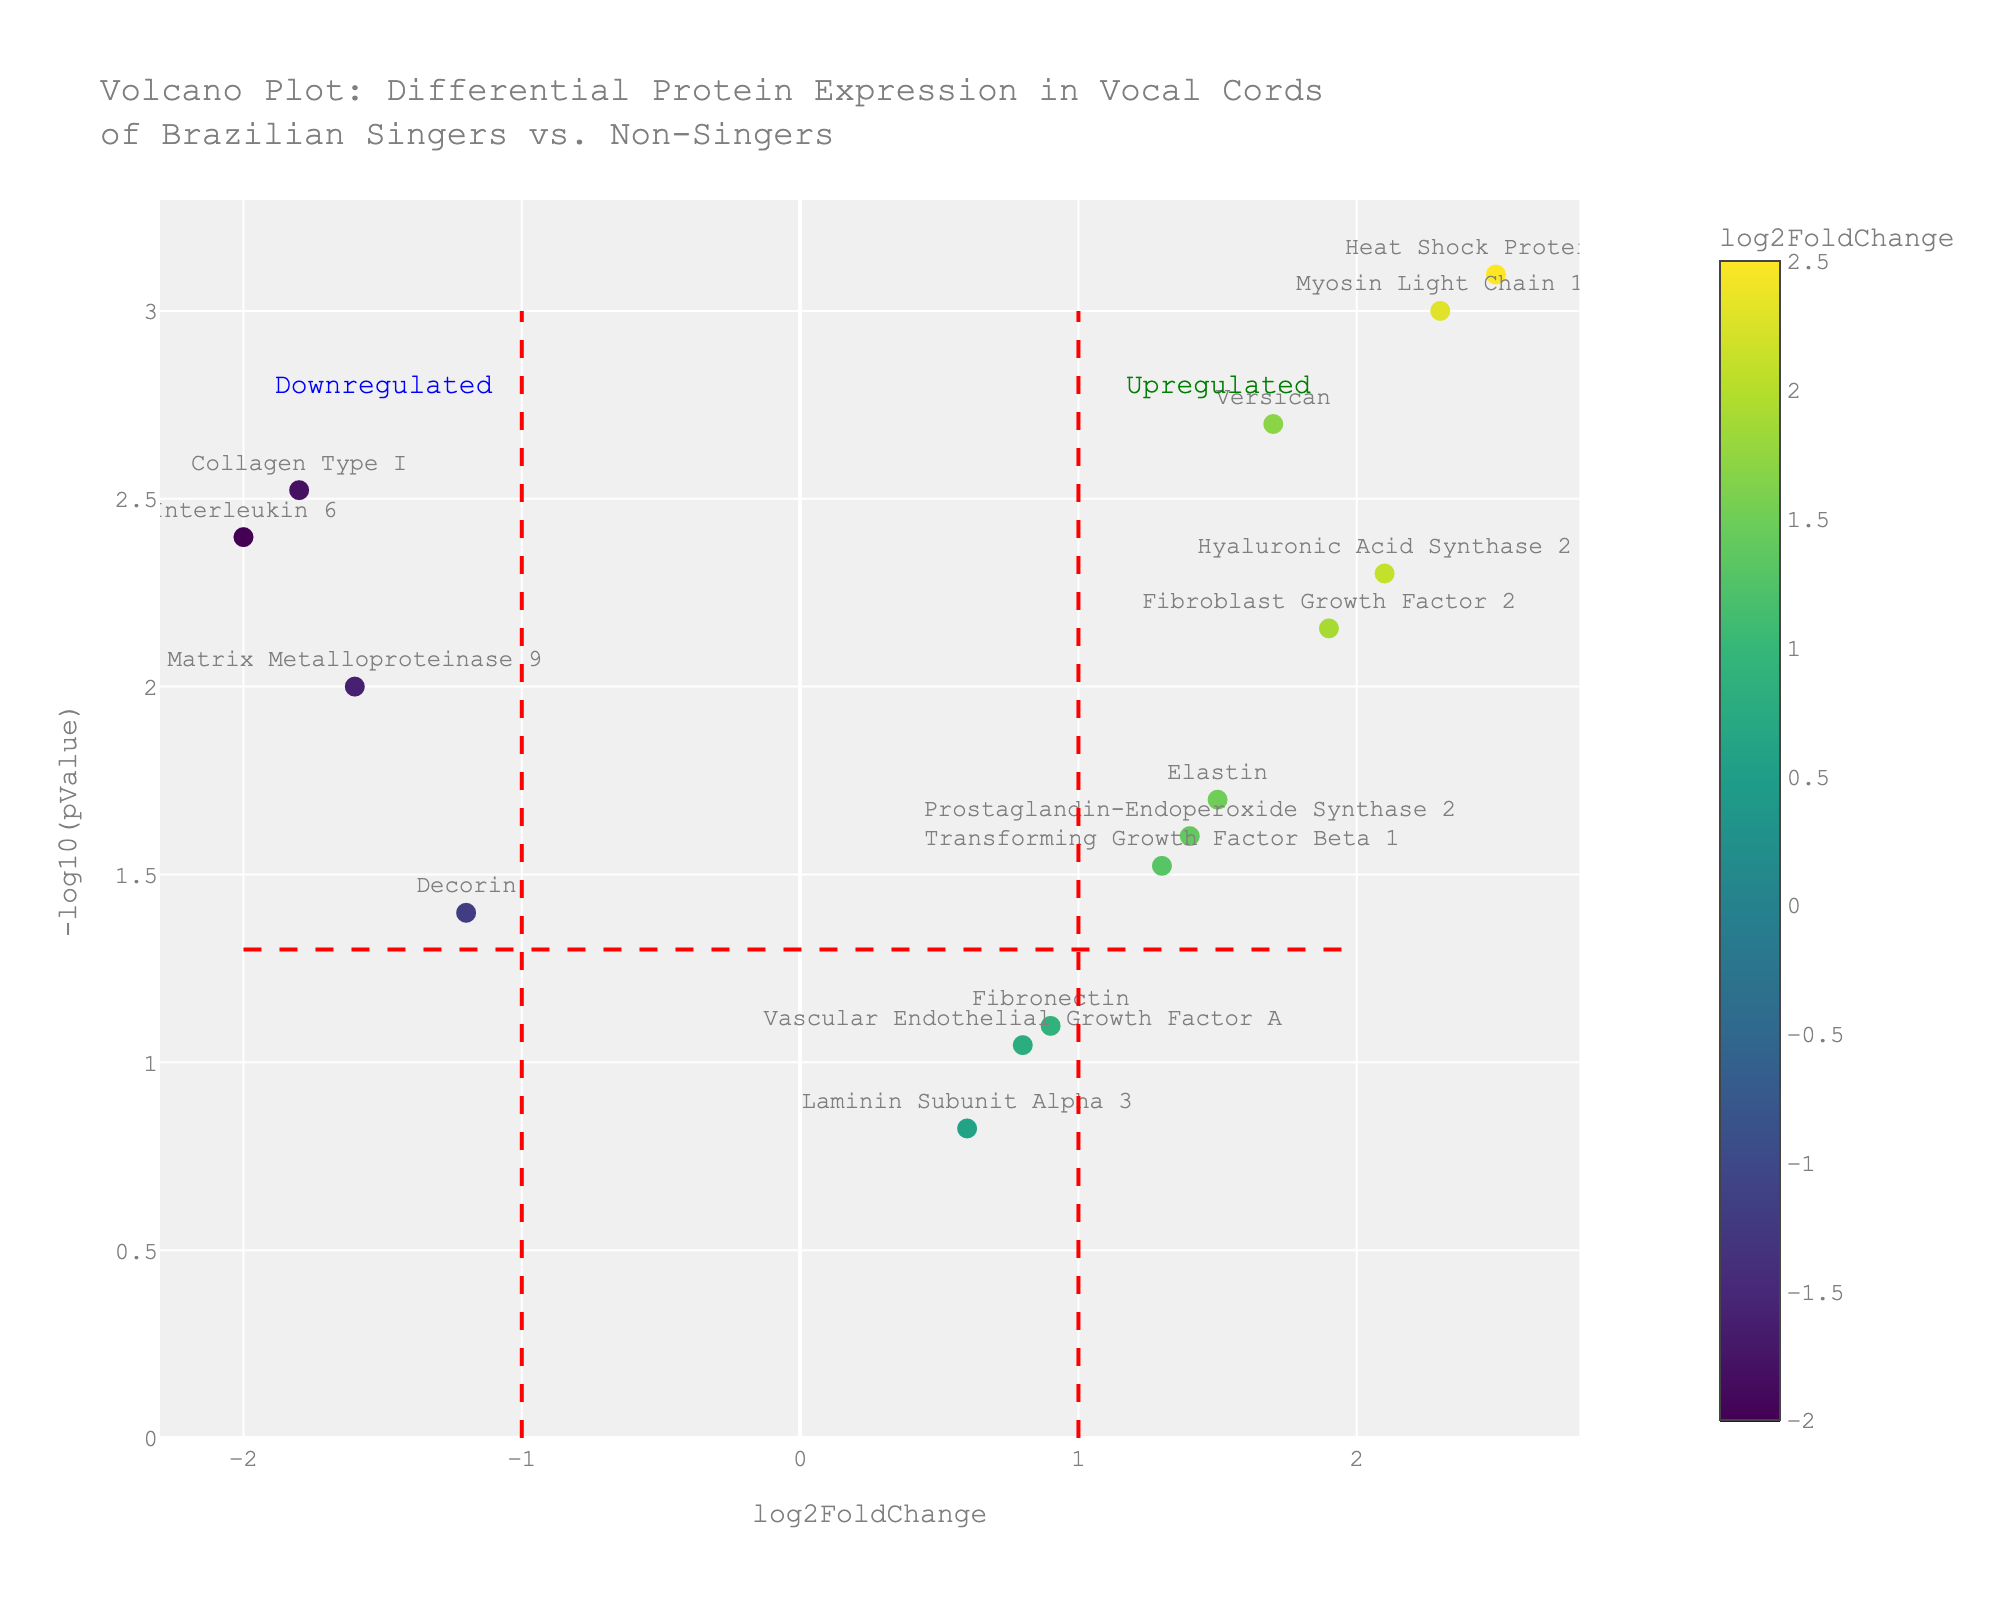What's the title of the figure? The title is usually found in a prominent position at the top of the figure and often summarizes what the plot is about. In this case, the title is "Volcano Plot: Differential Protein Expression in Vocal Cords of Brazilian Singers vs. Non-Singers".
Answer: Volcano Plot: Differential Protein Expression in Vocal Cords of Brazilian Singers vs. Non-Singers What are the labels of the x-axis and y-axis? Axis labels provide information about what each axis represents. The x-axis label is "log2FoldChange", which represents the log2 fold changes in protein expression. The y-axis label is "-log10(pValue)", which represents the negative log10 of the p-values associated with the protein expression changes.
Answer: x-axis: log2FoldChange, y-axis: -log10(pValue) How many proteins have a log2FoldChange greater than 2? To determine this, you would examine the data points on the plot with x-values greater than 2. Only one data point (Heat Shock Protein 70) has a log2FoldChange greater than 2.
Answer: 1 Which protein has the highest -log10(pValue)? The highest -log10(pValue) can be found by looking for the data point that is highest on the y-axis. Heat Shock Protein 70 has the highest -log10(pValue).
Answer: Heat Shock Protein 70 How many proteins have a p-value less than 0.01? To find this, look for data points with y-values greater than -log10(0.01), which is 2. These proteins are Myosin Light Chain 1, Collagen Type I, Hyaluronic Acid Synthase 2, Versican, Interleukin 6, and Heat Shock Protein 70.
Answer: 6 Which proteins are considered significantly upregulated? Proteins considered significantly upregulated typically have log2FoldChanges greater than a threshold (e.g., 1) and p-values less than a threshold (e.g., 0.05). These proteins are Myosin Light Chain 1, Hyaluronic Acid Synthase 2, Versican, Fibroblast Growth Factor 2, Heat Shock Protein 70.
Answer: Myosin Light Chain 1, Hyaluronic Acid Synthase 2, Versican, Fibroblast Growth Factor 2, Heat Shock Protein 70 Which protein is the most downregulated and significantly expressed? The most downregulated protein would have the most negative log2FoldChange value and a significant p-value (typically below 0.05). Interleukin 6 has the lowest log2FoldChange (-2.0) and a p-value of 0.004, making it the most downregulated and significantly expressed protein.
Answer: Interleukin 6 What is the log2FoldChange of Decorin? Find the label for Decorin on the plot or refer to the data, then read off or note its x-value. The log2FoldChange for Decorin is -1.2.
Answer: -1.2 Is Vascular Endothelial Growth Factor A significantly expressed? To check significance, look at the p-value associated with this protein. If its -log10(pValue) is greater than 1.3, it is significant. The y-value (-log10(pValue)) for Vascular Endothelial Growth Factor A is less than 1.3 (log(pValue) is approximately 1.02), indicating it is not significantly expressed.
Answer: No 